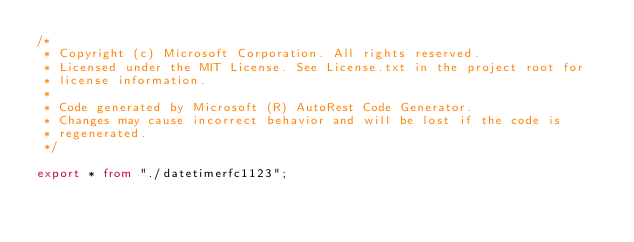<code> <loc_0><loc_0><loc_500><loc_500><_TypeScript_>/*
 * Copyright (c) Microsoft Corporation. All rights reserved.
 * Licensed under the MIT License. See License.txt in the project root for
 * license information.
 *
 * Code generated by Microsoft (R) AutoRest Code Generator.
 * Changes may cause incorrect behavior and will be lost if the code is
 * regenerated.
 */

export * from "./datetimerfc1123";
</code> 